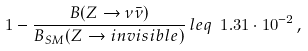<formula> <loc_0><loc_0><loc_500><loc_500>1 - \frac { B ( Z \to \nu \bar { \nu } ) } { B _ { S M } ( Z \to i n v i s i b l e ) } \, l e q \ 1 . 3 1 \cdot 1 0 ^ { - 2 } \, ,</formula> 